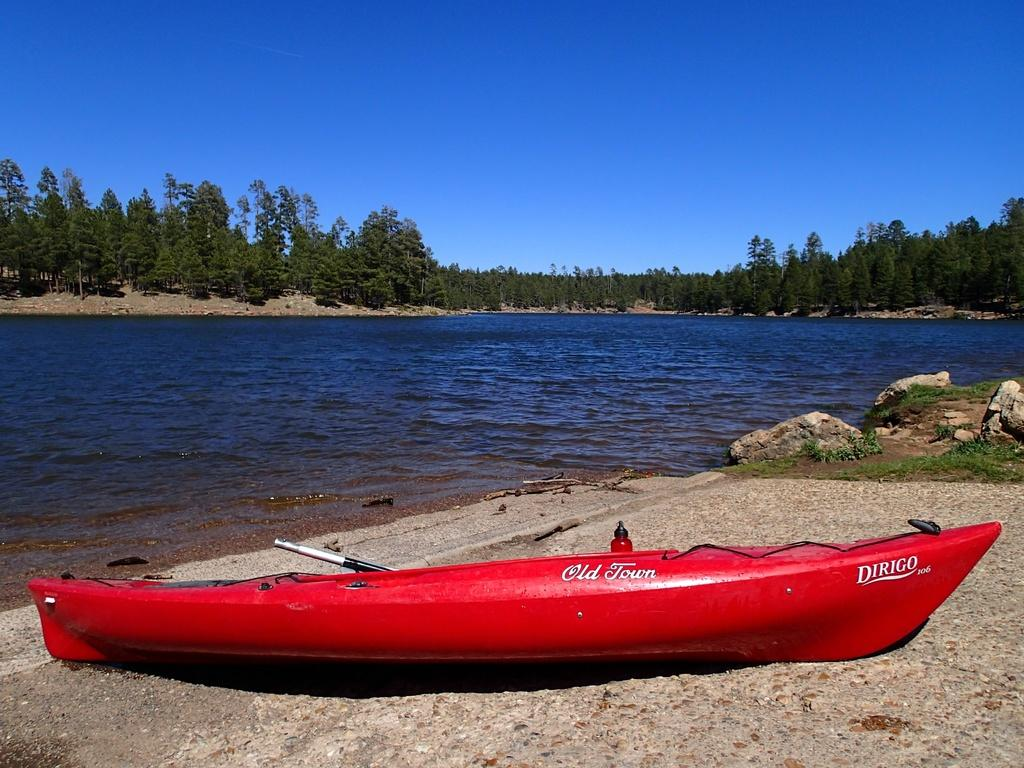What is the color of the boat in the picture? The boat in the picture is red. What can be found on the floor in the image? There are rocks and grass on the floor. What is visible in the background of the picture? There is a lake and trees in the backdrop of the picture. How much salt is present in the lake in the image? There is no information about salt in the lake in the image, so it cannot be determined. 